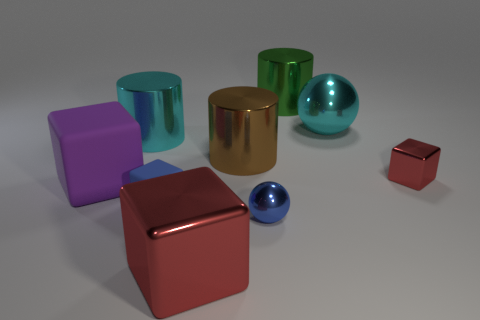There is a shiny cube in front of the blue rubber block; does it have the same color as the small cube right of the blue ball?
Your answer should be compact. Yes. There is a red cube behind the purple rubber object; is it the same size as the purple thing?
Provide a succinct answer. No. There is a tiny thing left of the red thing left of the cyan metallic ball; what shape is it?
Your answer should be compact. Cube. There is a cyan object that is to the right of the big shiny object in front of the large matte cube; how big is it?
Provide a short and direct response. Large. What color is the big rubber cube behind the small blue rubber thing?
Make the answer very short. Purple. What is the size of the brown object that is made of the same material as the large cyan cylinder?
Offer a very short reply. Large. How many blue objects have the same shape as the brown thing?
Your answer should be compact. 0. There is a ball that is the same size as the green shiny object; what material is it?
Give a very brief answer. Metal. Are there any tiny cyan spheres that have the same material as the green object?
Ensure brevity in your answer.  No. There is a metallic object that is to the left of the brown shiny cylinder and behind the tiny blue matte object; what is its color?
Make the answer very short. Cyan. 